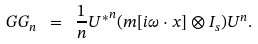Convert formula to latex. <formula><loc_0><loc_0><loc_500><loc_500>\ G G _ { n } \ = \ \frac { 1 } { n } { U ^ { * } } ^ { n } ( m [ i \omega \cdot x ] \otimes I _ { s } ) U ^ { n } .</formula> 